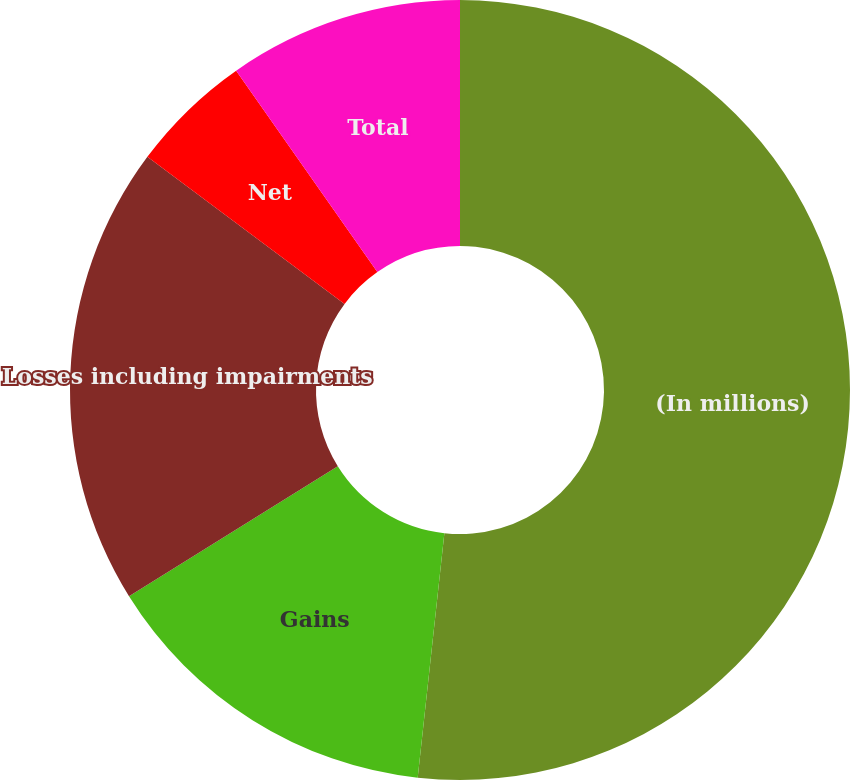Convert chart. <chart><loc_0><loc_0><loc_500><loc_500><pie_chart><fcel>(In millions)<fcel>Gains<fcel>Losses including impairments<fcel>Net<fcel>Total<nl><fcel>51.73%<fcel>14.4%<fcel>19.07%<fcel>5.07%<fcel>9.73%<nl></chart> 